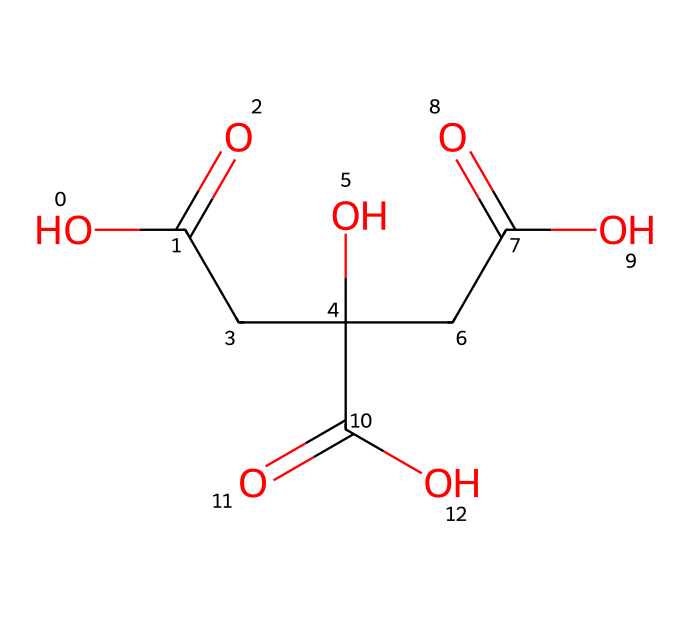What is the chemical name of the compound represented by the SMILES? The SMILES indicates a specific structure consisting of three carboxylic acid groups, suggesting the name citric acid, which is well-known for its presence in citrus fruits.
Answer: citric acid How many carboxylic acid groups are present in this molecule? The structure shows three distinct -COOH groups, which are characteristic of carboxylic acids and indicate that the molecule contains three acidic functional groups.
Answer: three What type of functional groups are present in citric acid? By examining the structure, we can identify -COOH groups which are carboxylic acids, along with hydroxyl (-OH) groups that are present, indicating the molecule's acidic and alcoholic properties.
Answer: carboxylic acids and hydroxyl groups What is the total number of carbon atoms in citric acid? Scrutinizing the structure reveals there are six carbon atoms linked in the molecule, as they can be counted directly from the representation of the structure provided by the SMILES.
Answer: six Is citric acid a strong or weak acid? Due to the presence of multiple carboxylic acid groups contributing to its acidity, citric acid is classified as a weak acid, which implies partial ionization when dissolved in water.
Answer: weak acid How does the presence of hydroxyl groups affect the properties of citric acid? Hydroxyl groups can increase the solubility of citric acid in water and may contribute to hydrogen bonding, enhancing its reactivity and interactions with other molecules.
Answer: increases solubility What role does citric acid play in common household cleaners? Citric acid acts as a chelating agent, helping to bind metal ions, which improves the effectiveness of cleaning and enhances the removal of dirt and stains.
Answer: chelating agent 